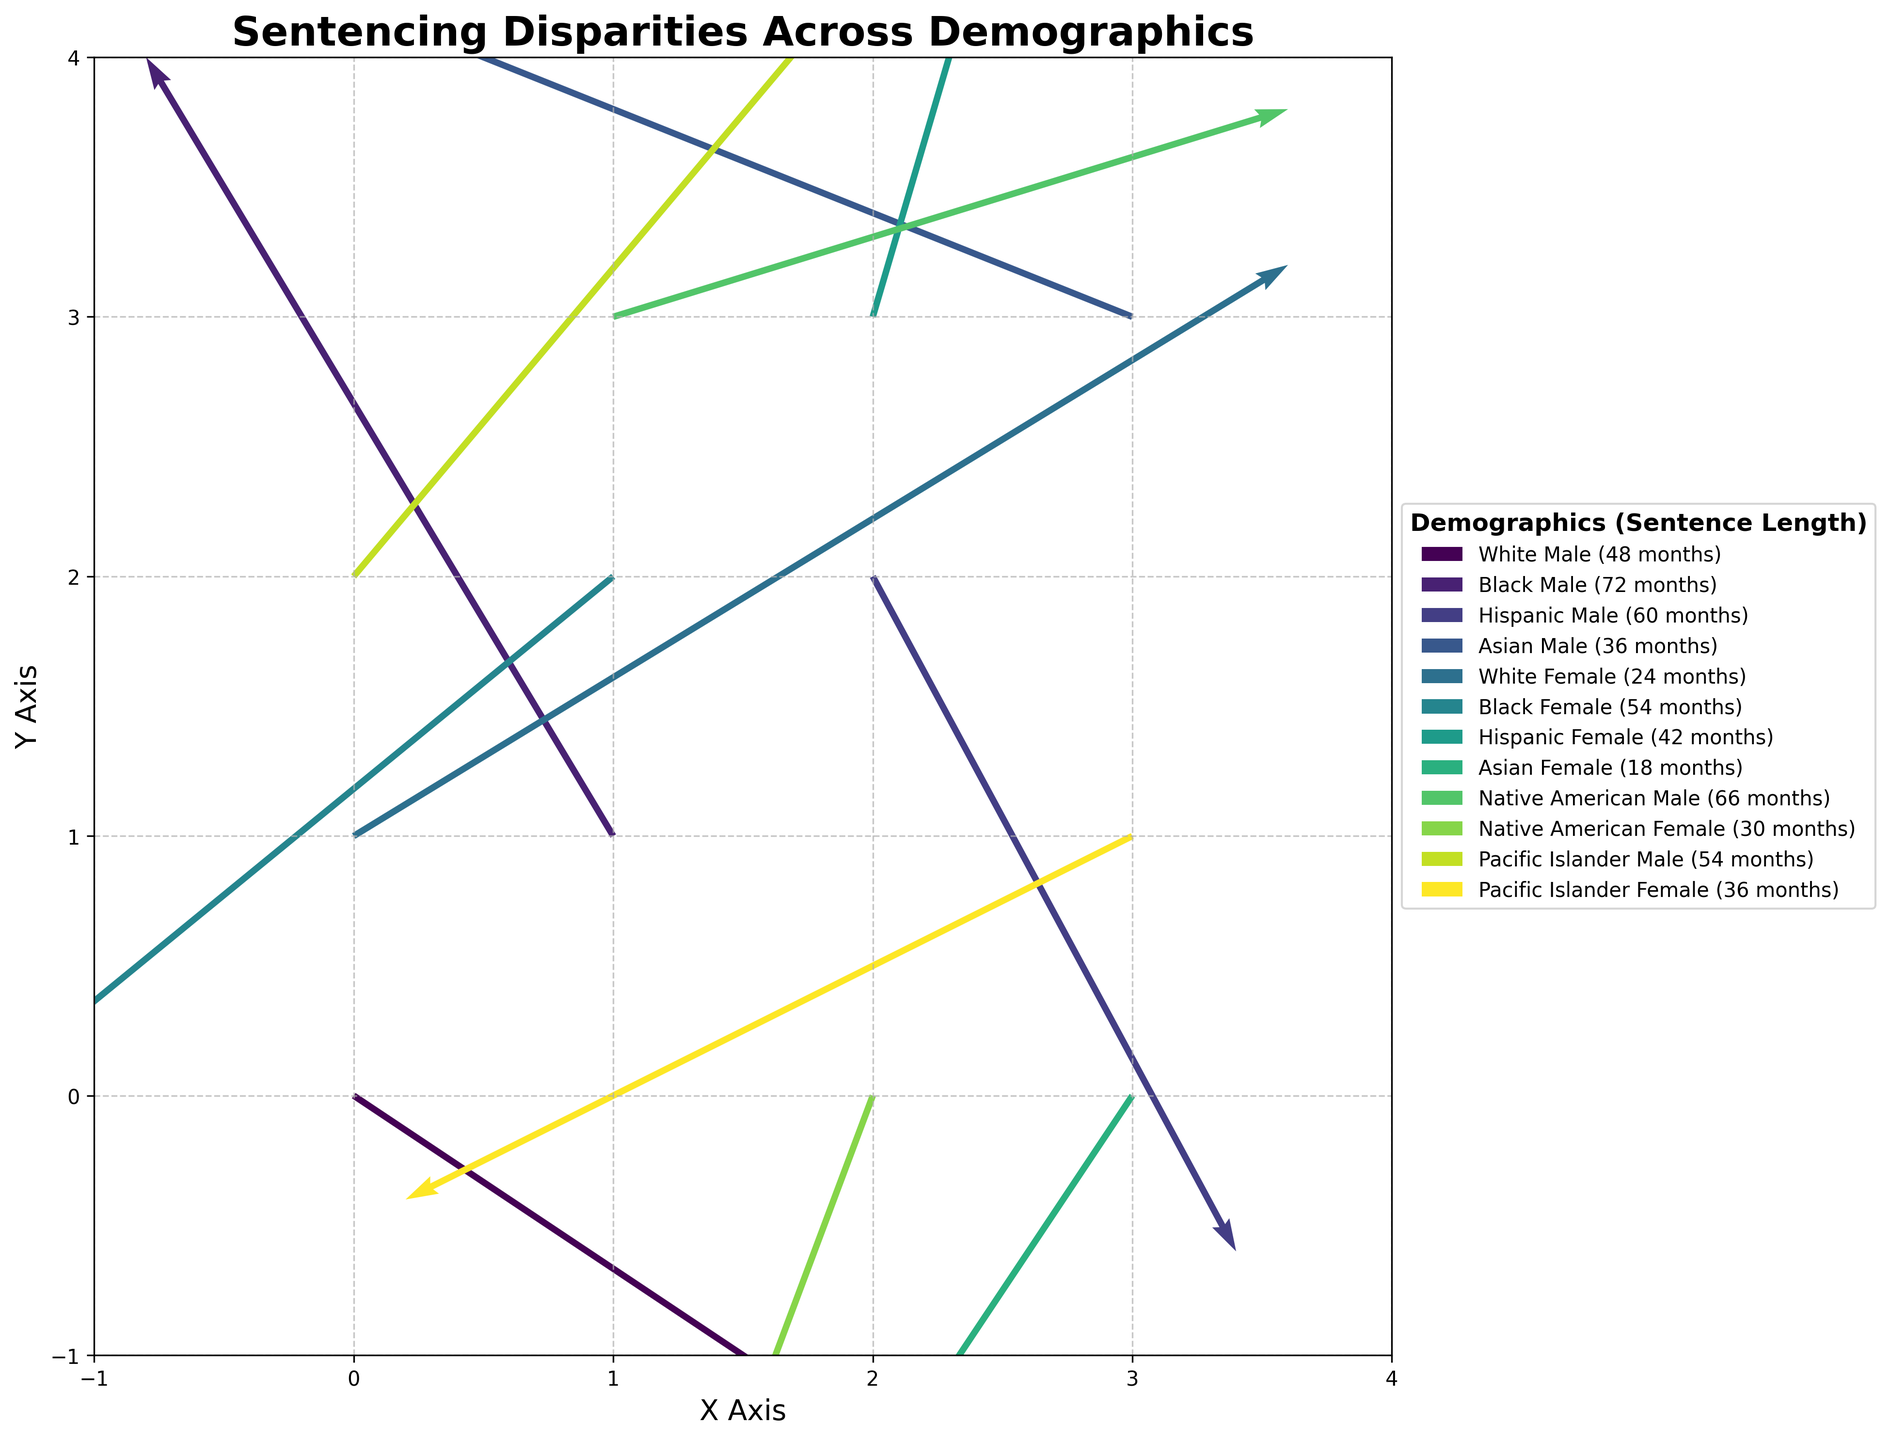What is the title of the figure? To find the title, observe the text at the top of the plot.
Answer: Sentencing Disparities Across Demographics How many arrows represent Black Male demographic? Locate the arrow labels and count the number that are labeled "Black Male."
Answer: 1 Which demographic group has the longest sentence length? Look for the demographic indicated in the arrow label with the highest value following "Sentence Length."
Answer: Black Male (72 months) Which direction does the arrow for Asian Male point? Observe the starting and ending points of the arrow labeled "Asian Male."
Answer: Left and slightly down Compare the sentence length for White Male and Hispanic Male. Which one is longer? Check the arrow labels for both demographics and compare the numbers next to "Sentence Length."
Answer: Hispanic Male (60 months) is longer than White Male (48 months) What is the range of X values shown on the plot? Observe the x-axis to identify the minimum and maximum values displayed.
Answer: -1 to 4 What is the vector representation (U, V) of Native American Female? Locate the arrow labeled "Native American Female" and record the values associated with U and V.
Answer: (-0.6, -1.6) Which demographic is associated with the arrow at coordinates (0, 1)? Find the arrow starting at (0, 1) and look at its label.
Answer: White Female What is the average sentence length for the demographic groups represented above the x-axis? Consider the Sentence Length values for all arrows with Y values greater than 0. Average = (24 + 54 + 42 + 66 + 54 + 36) / 6 = (276 / 6)
Answer: 46 months How many arrows point to the right? Count the number of arrows with a positive U value.
Answer: 5 